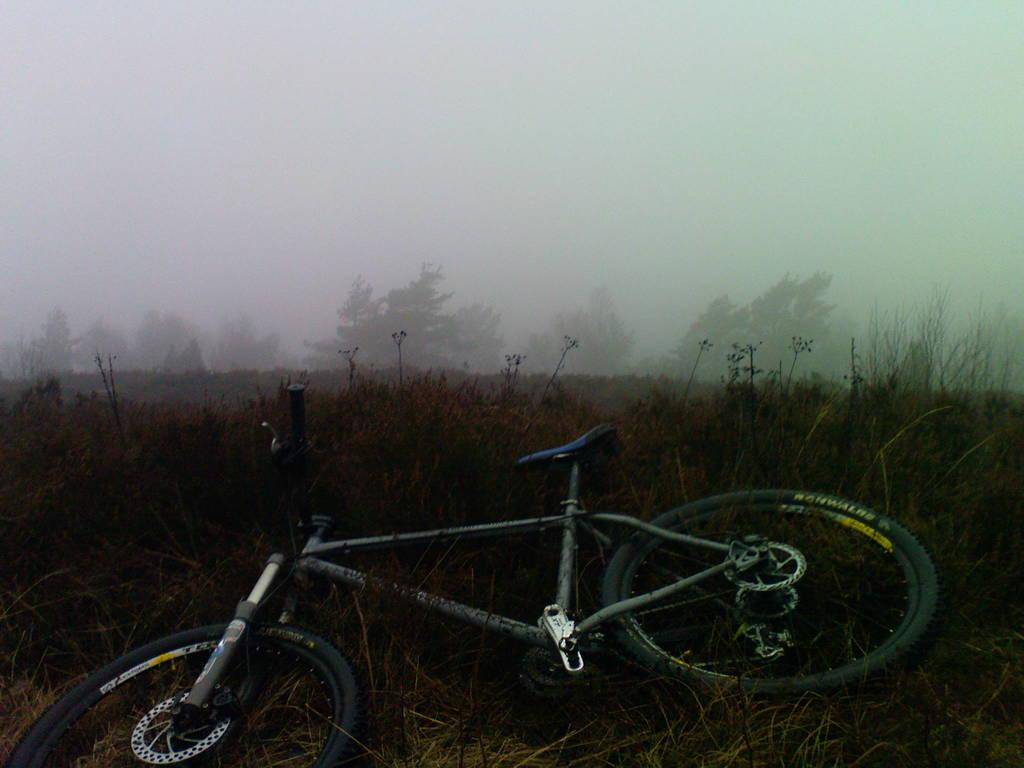What is the main object in the image? There is a cycle in the image. Where is the cycle located in relation to other objects? The cycle is beside some plants. What can be seen in the middle of the image? There are trees in the middle of the image. What is visible in the background of the image? The sky is visible in the background of the image. What type of loaf is being baked in the oven in the image? There is no oven or loaf present in the image; it features a cycle beside some plants and trees in the middle of the image. What rhythm is the country playing in the image? There is no country or music present in the image; it only features a cycle, plants, trees, and the sky in the background. 